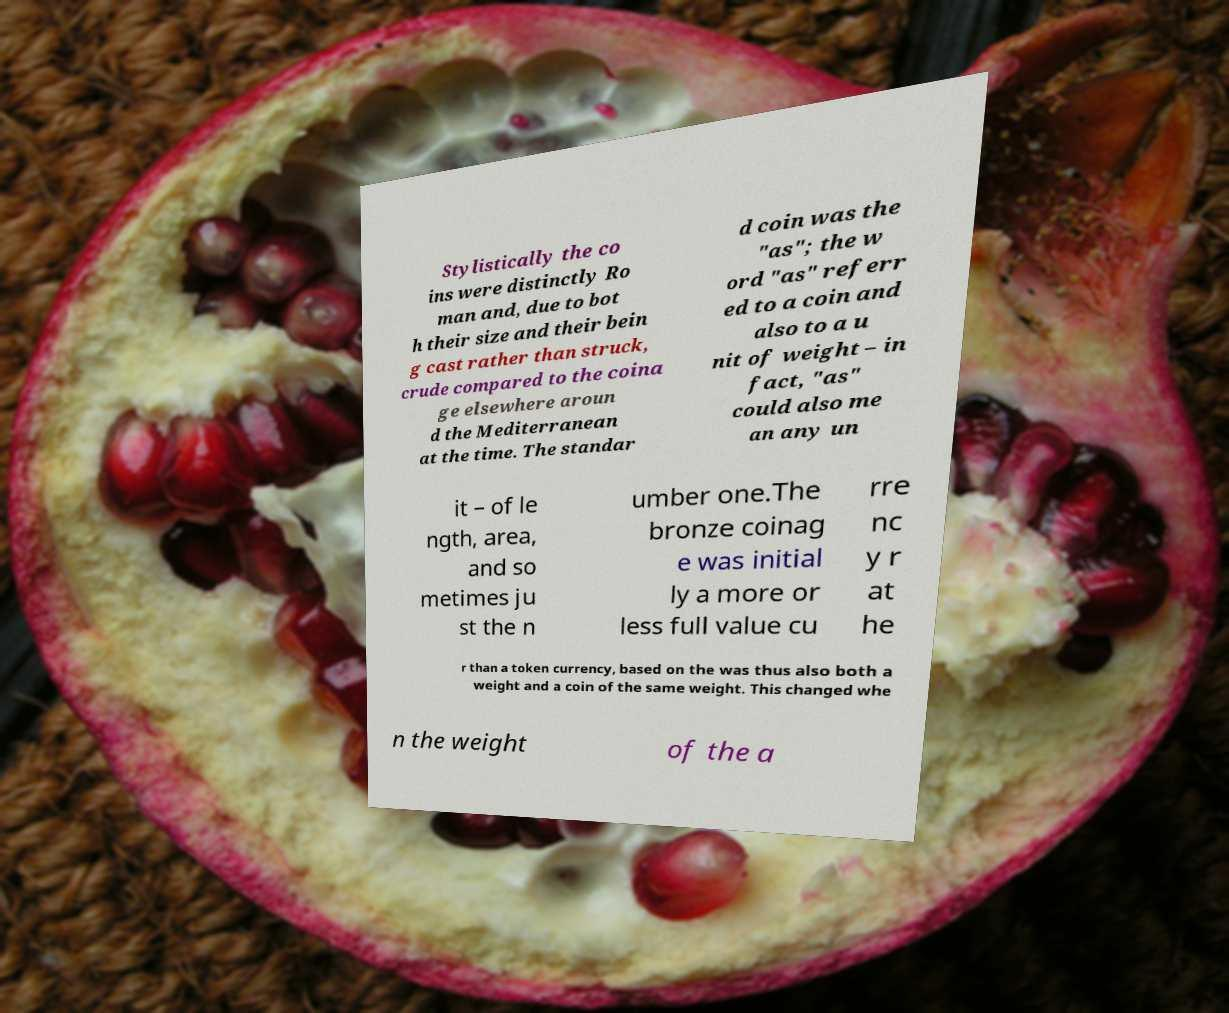There's text embedded in this image that I need extracted. Can you transcribe it verbatim? Stylistically the co ins were distinctly Ro man and, due to bot h their size and their bein g cast rather than struck, crude compared to the coina ge elsewhere aroun d the Mediterranean at the time. The standar d coin was the "as"; the w ord "as" referr ed to a coin and also to a u nit of weight – in fact, "as" could also me an any un it – of le ngth, area, and so metimes ju st the n umber one.The bronze coinag e was initial ly a more or less full value cu rre nc y r at he r than a token currency, based on the was thus also both a weight and a coin of the same weight. This changed whe n the weight of the a 